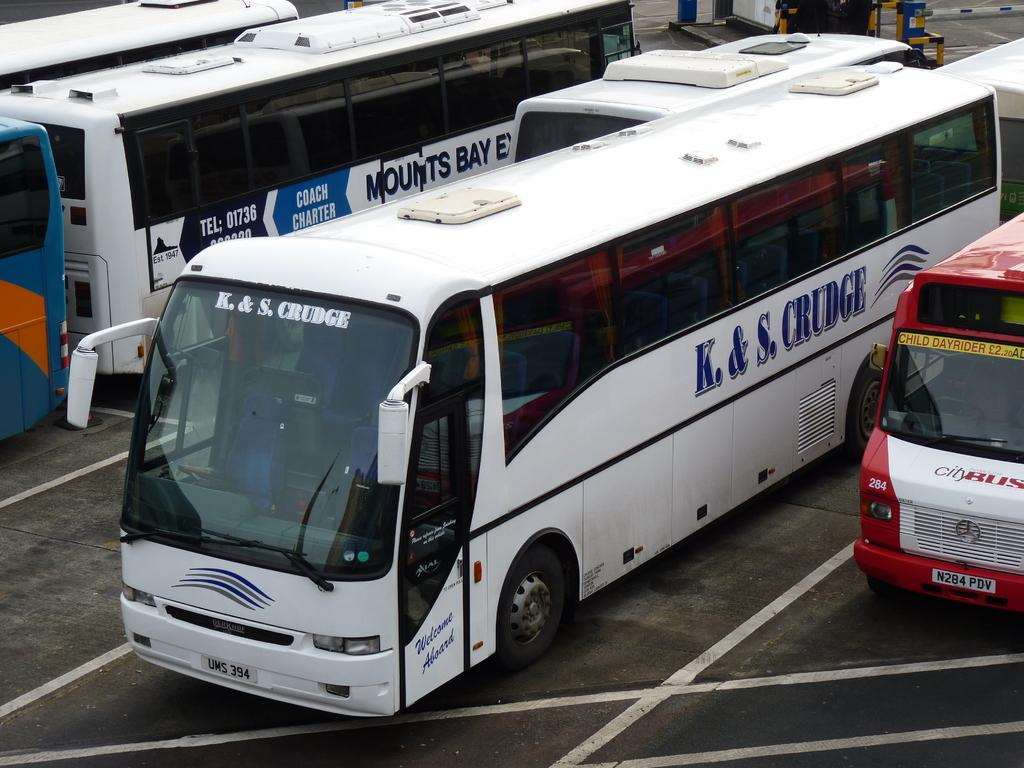<image>
Relay a brief, clear account of the picture shown. White tour bus that is labeled K & S Crudge 